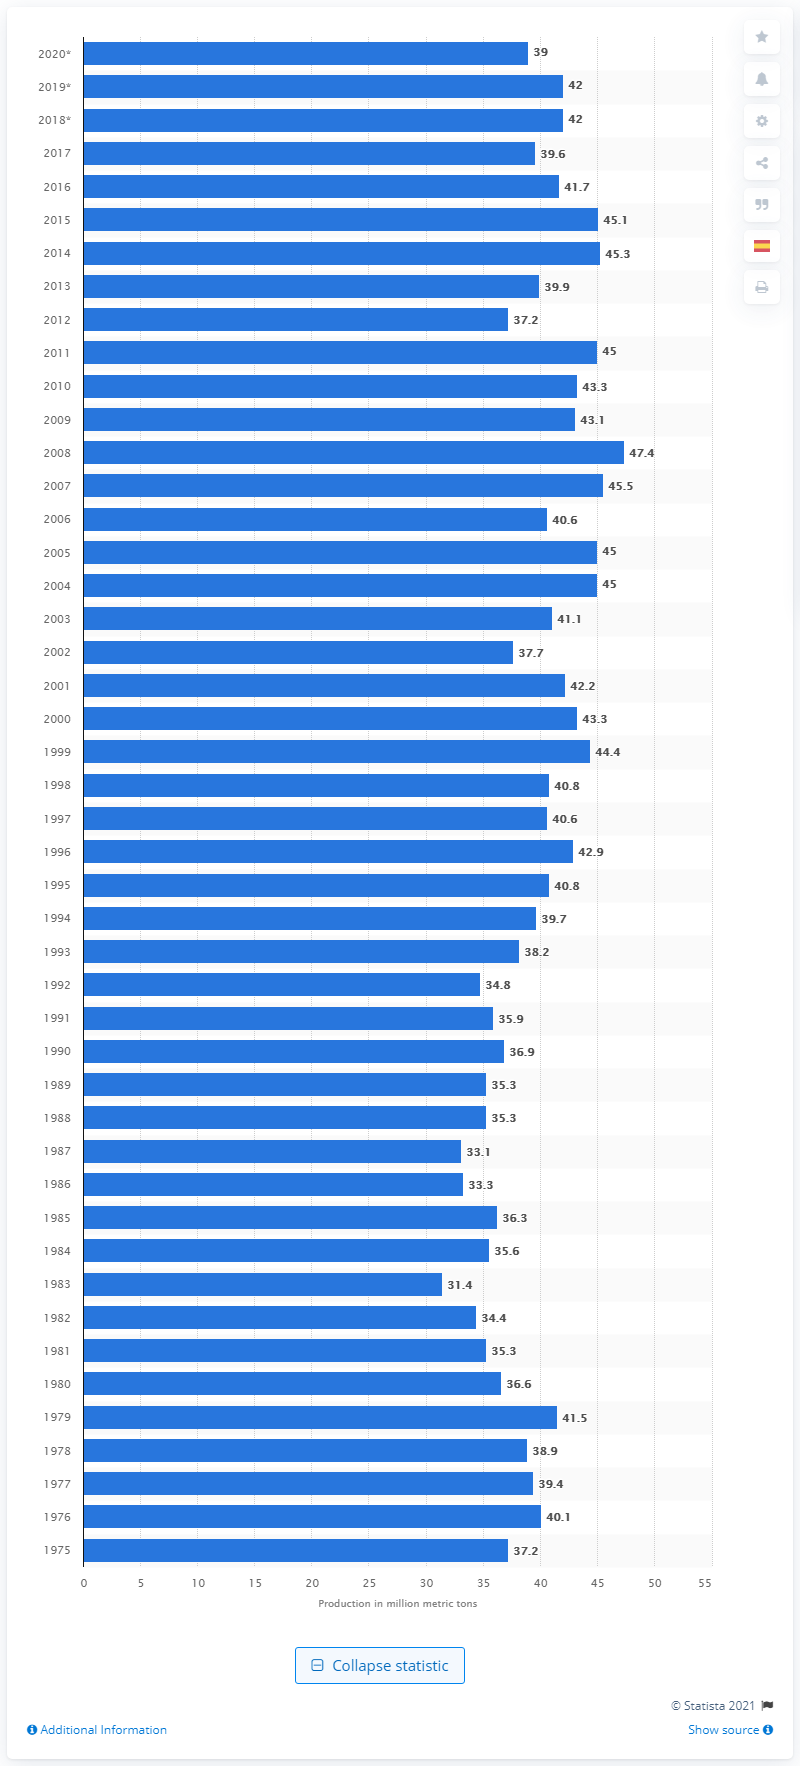Mention a couple of crucial points in this snapshot. In the year 2008, salt production set a record high. In 2008, it is estimated that 47,400 metric tons of salt were produced. In 2020, the United States produced approximately 39 million metric tons of salt. 